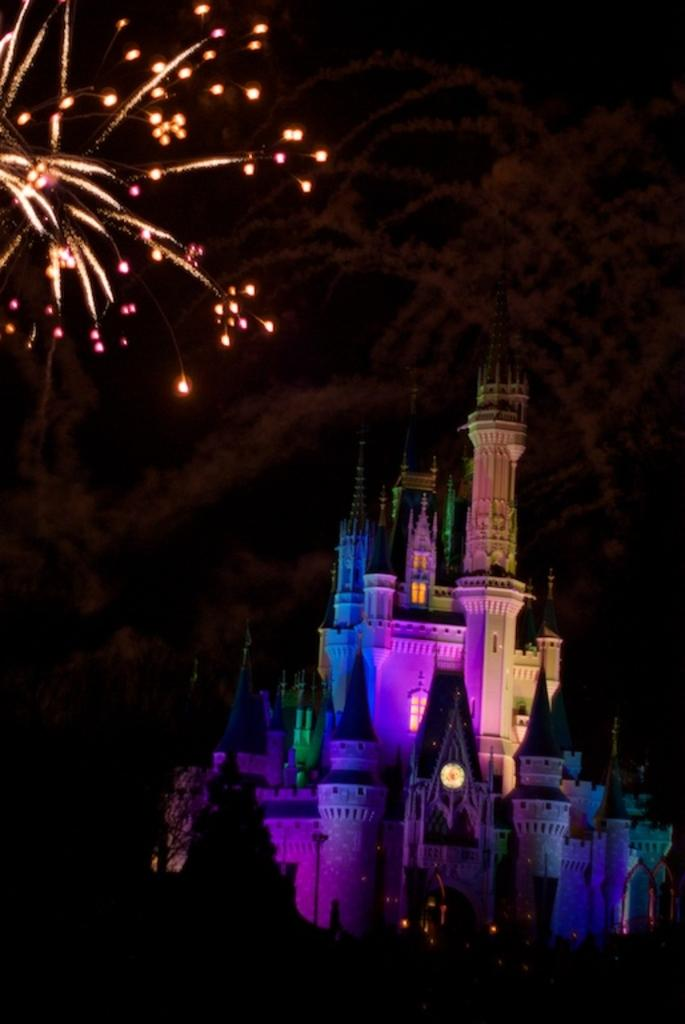What type of structure is present in the image? There is a building in the image. Can you describe any other elements in the image? Yes, there are lights visible in the image. What type of sand can be seen on the building in the image? There is no sand present on the building in the image. What season is depicted in the image? The provided facts do not give any information about the season, so it cannot be determined from the image. 